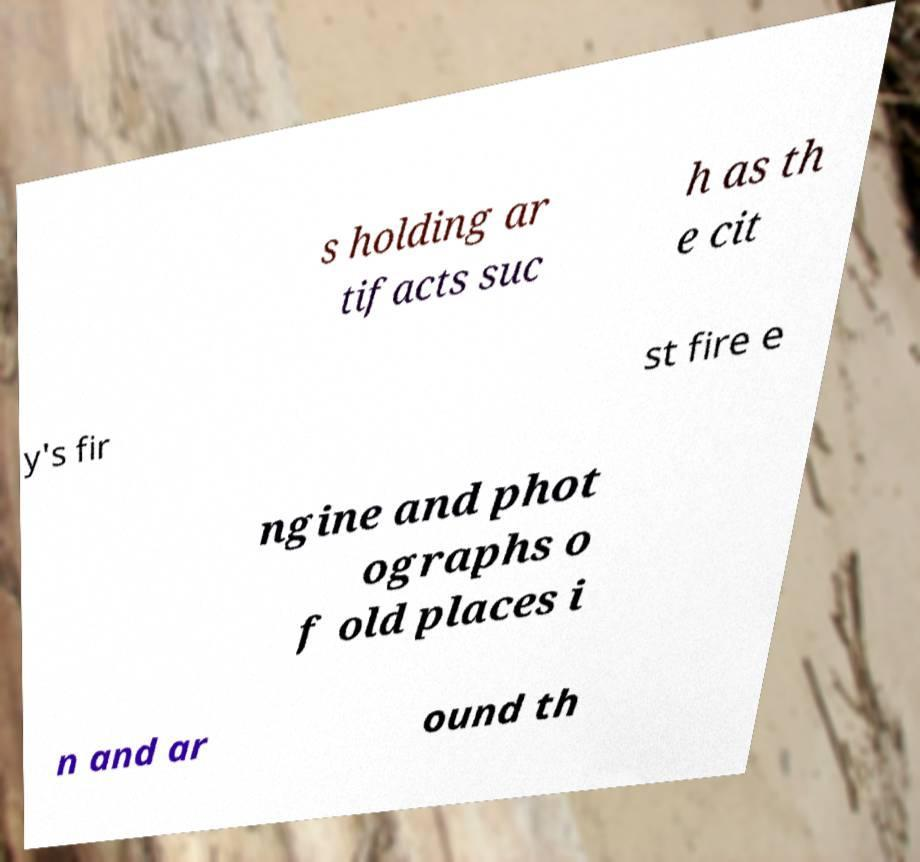Please read and relay the text visible in this image. What does it say? s holding ar tifacts suc h as th e cit y's fir st fire e ngine and phot ographs o f old places i n and ar ound th 